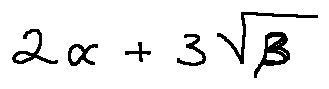Convert formula to latex. <formula><loc_0><loc_0><loc_500><loc_500>2 \alpha + 3 \sqrt { \beta }</formula> 